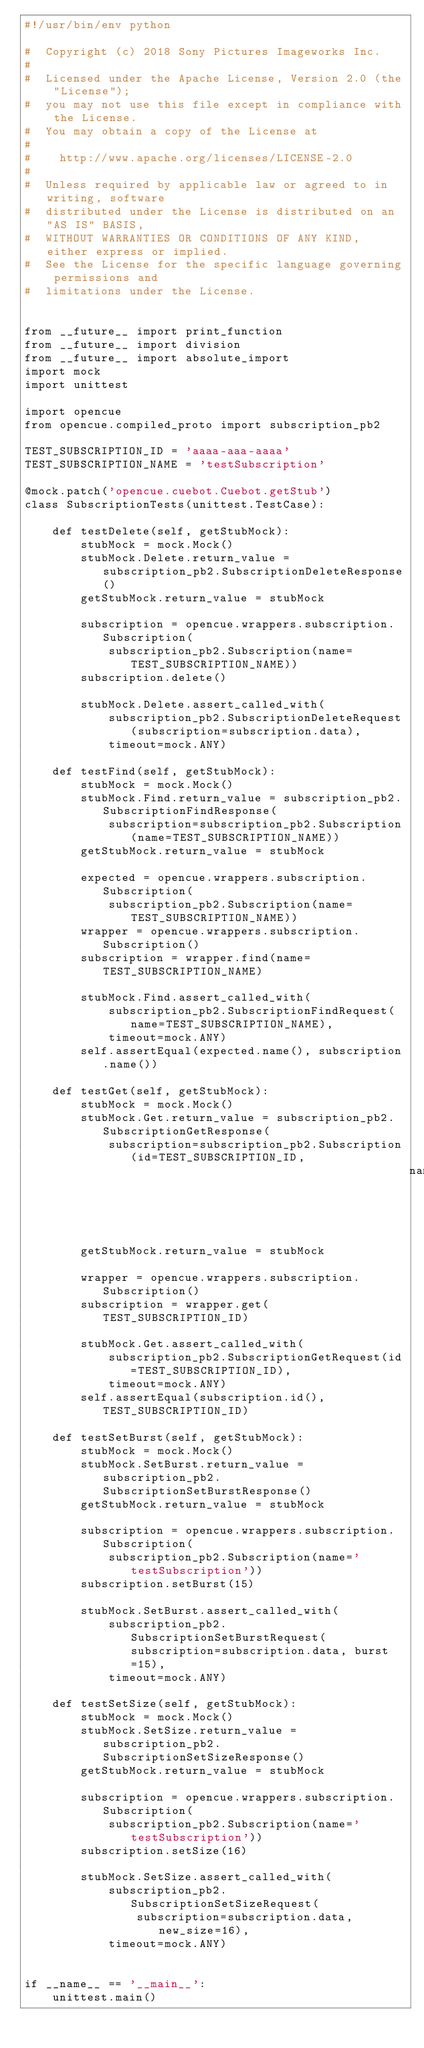<code> <loc_0><loc_0><loc_500><loc_500><_Python_>#!/usr/bin/env python

#  Copyright (c) 2018 Sony Pictures Imageworks Inc.
#
#  Licensed under the Apache License, Version 2.0 (the "License");
#  you may not use this file except in compliance with the License.
#  You may obtain a copy of the License at
#
#    http://www.apache.org/licenses/LICENSE-2.0
#
#  Unless required by applicable law or agreed to in writing, software
#  distributed under the License is distributed on an "AS IS" BASIS,
#  WITHOUT WARRANTIES OR CONDITIONS OF ANY KIND, either express or implied.
#  See the License for the specific language governing permissions and
#  limitations under the License.


from __future__ import print_function
from __future__ import division
from __future__ import absolute_import
import mock
import unittest

import opencue
from opencue.compiled_proto import subscription_pb2

TEST_SUBSCRIPTION_ID = 'aaaa-aaa-aaaa'
TEST_SUBSCRIPTION_NAME = 'testSubscription'

@mock.patch('opencue.cuebot.Cuebot.getStub')
class SubscriptionTests(unittest.TestCase):

    def testDelete(self, getStubMock):
        stubMock = mock.Mock()
        stubMock.Delete.return_value = subscription_pb2.SubscriptionDeleteResponse()
        getStubMock.return_value = stubMock

        subscription = opencue.wrappers.subscription.Subscription(
            subscription_pb2.Subscription(name=TEST_SUBSCRIPTION_NAME))
        subscription.delete()

        stubMock.Delete.assert_called_with(
            subscription_pb2.SubscriptionDeleteRequest(subscription=subscription.data),
            timeout=mock.ANY)

    def testFind(self, getStubMock):
        stubMock = mock.Mock()
        stubMock.Find.return_value = subscription_pb2.SubscriptionFindResponse(
            subscription=subscription_pb2.Subscription(name=TEST_SUBSCRIPTION_NAME))
        getStubMock.return_value = stubMock

        expected = opencue.wrappers.subscription.Subscription(
            subscription_pb2.Subscription(name=TEST_SUBSCRIPTION_NAME))
        wrapper = opencue.wrappers.subscription.Subscription()
        subscription = wrapper.find(name=TEST_SUBSCRIPTION_NAME)

        stubMock.Find.assert_called_with(
            subscription_pb2.SubscriptionFindRequest(name=TEST_SUBSCRIPTION_NAME),
            timeout=mock.ANY)
        self.assertEqual(expected.name(), subscription.name())

    def testGet(self, getStubMock):
        stubMock = mock.Mock()
        stubMock.Get.return_value = subscription_pb2.SubscriptionGetResponse(
            subscription=subscription_pb2.Subscription(id=TEST_SUBSCRIPTION_ID,
                                                       name=TEST_SUBSCRIPTION_NAME))
        getStubMock.return_value = stubMock

        wrapper = opencue.wrappers.subscription.Subscription()
        subscription = wrapper.get(TEST_SUBSCRIPTION_ID)

        stubMock.Get.assert_called_with(
            subscription_pb2.SubscriptionGetRequest(id=TEST_SUBSCRIPTION_ID),
            timeout=mock.ANY)
        self.assertEqual(subscription.id(), TEST_SUBSCRIPTION_ID)

    def testSetBurst(self, getStubMock):
        stubMock = mock.Mock()
        stubMock.SetBurst.return_value = subscription_pb2.SubscriptionSetBurstResponse()
        getStubMock.return_value = stubMock

        subscription = opencue.wrappers.subscription.Subscription(
            subscription_pb2.Subscription(name='testSubscription'))
        subscription.setBurst(15)

        stubMock.SetBurst.assert_called_with(
            subscription_pb2.SubscriptionSetBurstRequest(subscription=subscription.data, burst=15),
            timeout=mock.ANY)

    def testSetSize(self, getStubMock):
        stubMock = mock.Mock()
        stubMock.SetSize.return_value = subscription_pb2.SubscriptionSetSizeResponse()
        getStubMock.return_value = stubMock

        subscription = opencue.wrappers.subscription.Subscription(
            subscription_pb2.Subscription(name='testSubscription'))
        subscription.setSize(16)

        stubMock.SetSize.assert_called_with(
            subscription_pb2.SubscriptionSetSizeRequest(
                subscription=subscription.data, new_size=16),
            timeout=mock.ANY)


if __name__ == '__main__':
    unittest.main()
</code> 